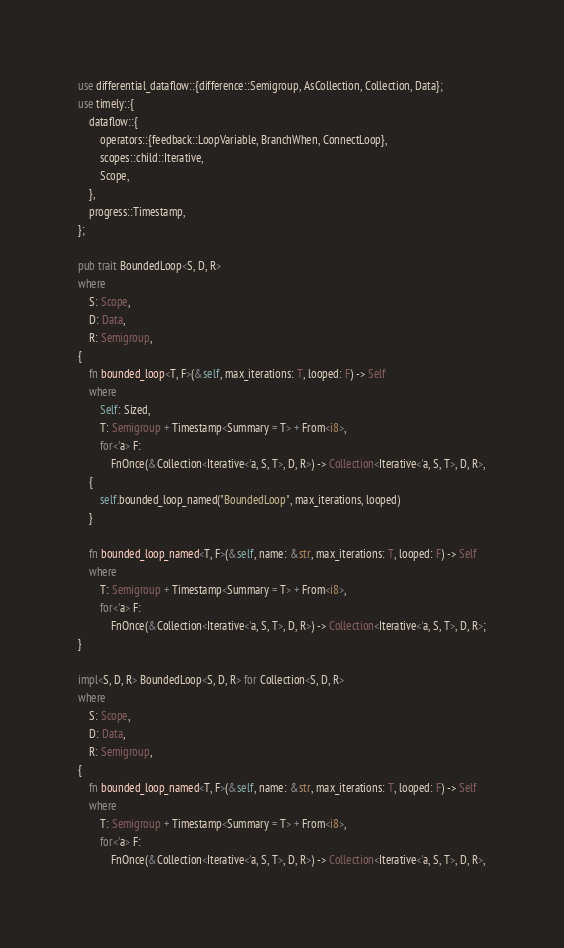<code> <loc_0><loc_0><loc_500><loc_500><_Rust_>use differential_dataflow::{difference::Semigroup, AsCollection, Collection, Data};
use timely::{
    dataflow::{
        operators::{feedback::LoopVariable, BranchWhen, ConnectLoop},
        scopes::child::Iterative,
        Scope,
    },
    progress::Timestamp,
};

pub trait BoundedLoop<S, D, R>
where
    S: Scope,
    D: Data,
    R: Semigroup,
{
    fn bounded_loop<T, F>(&self, max_iterations: T, looped: F) -> Self
    where
        Self: Sized,
        T: Semigroup + Timestamp<Summary = T> + From<i8>,
        for<'a> F:
            FnOnce(&Collection<Iterative<'a, S, T>, D, R>) -> Collection<Iterative<'a, S, T>, D, R>,
    {
        self.bounded_loop_named("BoundedLoop", max_iterations, looped)
    }

    fn bounded_loop_named<T, F>(&self, name: &str, max_iterations: T, looped: F) -> Self
    where
        T: Semigroup + Timestamp<Summary = T> + From<i8>,
        for<'a> F:
            FnOnce(&Collection<Iterative<'a, S, T>, D, R>) -> Collection<Iterative<'a, S, T>, D, R>;
}

impl<S, D, R> BoundedLoop<S, D, R> for Collection<S, D, R>
where
    S: Scope,
    D: Data,
    R: Semigroup,
{
    fn bounded_loop_named<T, F>(&self, name: &str, max_iterations: T, looped: F) -> Self
    where
        T: Semigroup + Timestamp<Summary = T> + From<i8>,
        for<'a> F:
            FnOnce(&Collection<Iterative<'a, S, T>, D, R>) -> Collection<Iterative<'a, S, T>, D, R>,</code> 